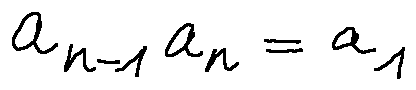<formula> <loc_0><loc_0><loc_500><loc_500>a _ { n - 1 } a _ { n } = a _ { 1 }</formula> 